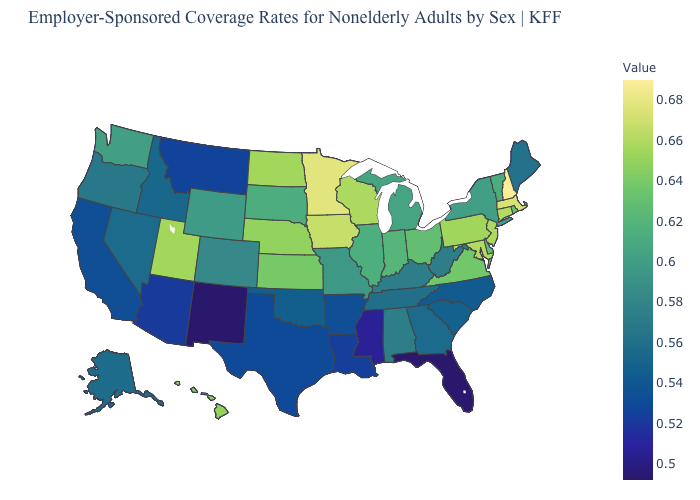Does California have a lower value than Florida?
Quick response, please. No. Does New Hampshire have the highest value in the Northeast?
Short answer required. Yes. Is the legend a continuous bar?
Quick response, please. Yes. Among the states that border Louisiana , which have the highest value?
Concise answer only. Arkansas. Does Kansas have a lower value than Colorado?
Be succinct. No. 